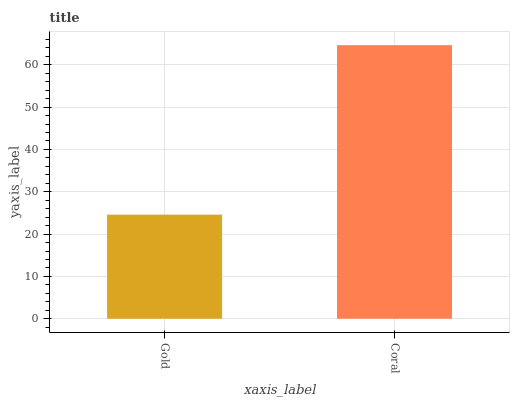Is Gold the minimum?
Answer yes or no. Yes. Is Coral the maximum?
Answer yes or no. Yes. Is Coral the minimum?
Answer yes or no. No. Is Coral greater than Gold?
Answer yes or no. Yes. Is Gold less than Coral?
Answer yes or no. Yes. Is Gold greater than Coral?
Answer yes or no. No. Is Coral less than Gold?
Answer yes or no. No. Is Coral the high median?
Answer yes or no. Yes. Is Gold the low median?
Answer yes or no. Yes. Is Gold the high median?
Answer yes or no. No. Is Coral the low median?
Answer yes or no. No. 